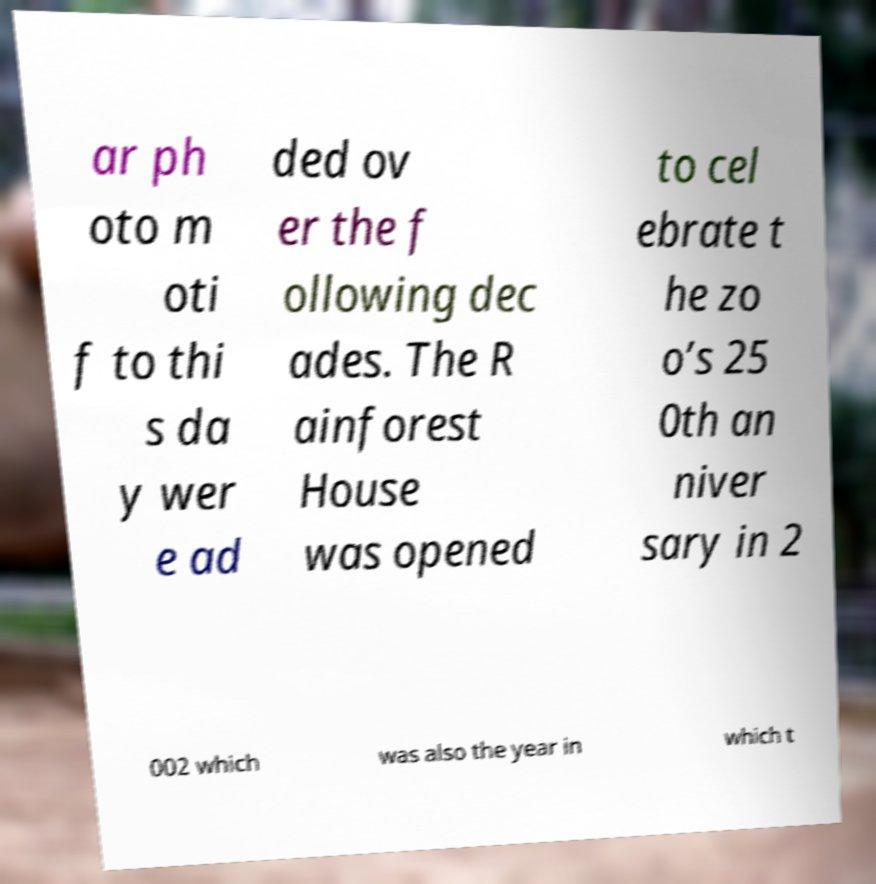For documentation purposes, I need the text within this image transcribed. Could you provide that? ar ph oto m oti f to thi s da y wer e ad ded ov er the f ollowing dec ades. The R ainforest House was opened to cel ebrate t he zo o’s 25 0th an niver sary in 2 002 which was also the year in which t 